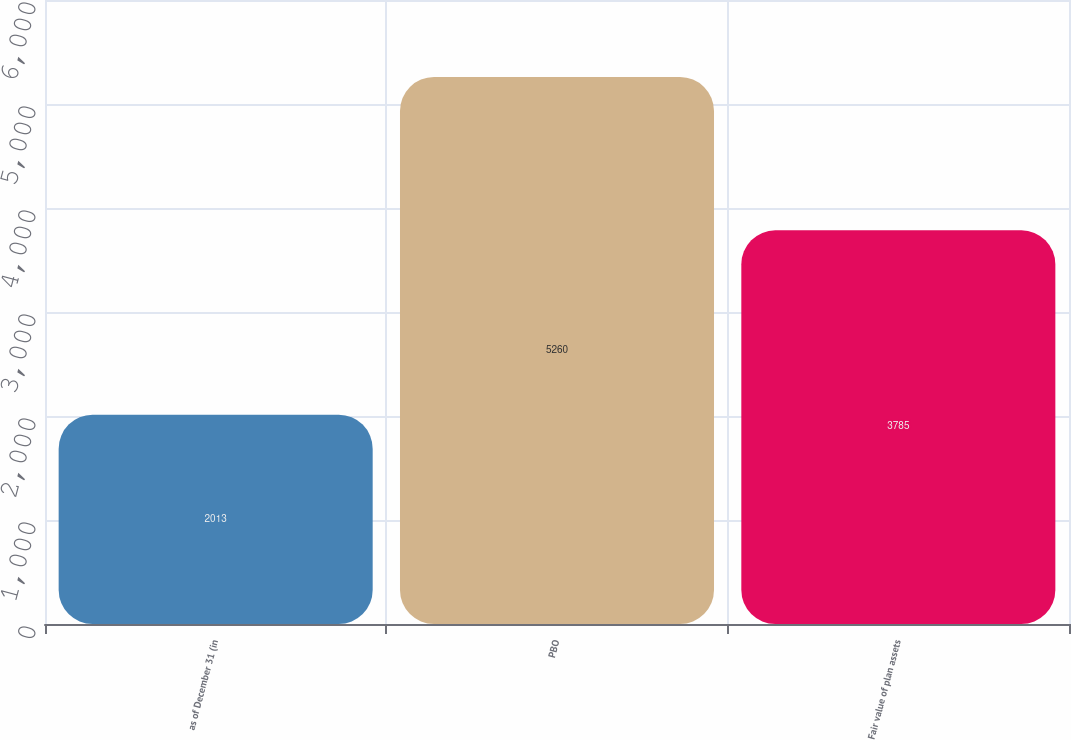Convert chart. <chart><loc_0><loc_0><loc_500><loc_500><bar_chart><fcel>as of December 31 (in<fcel>PBO<fcel>Fair value of plan assets<nl><fcel>2013<fcel>5260<fcel>3785<nl></chart> 